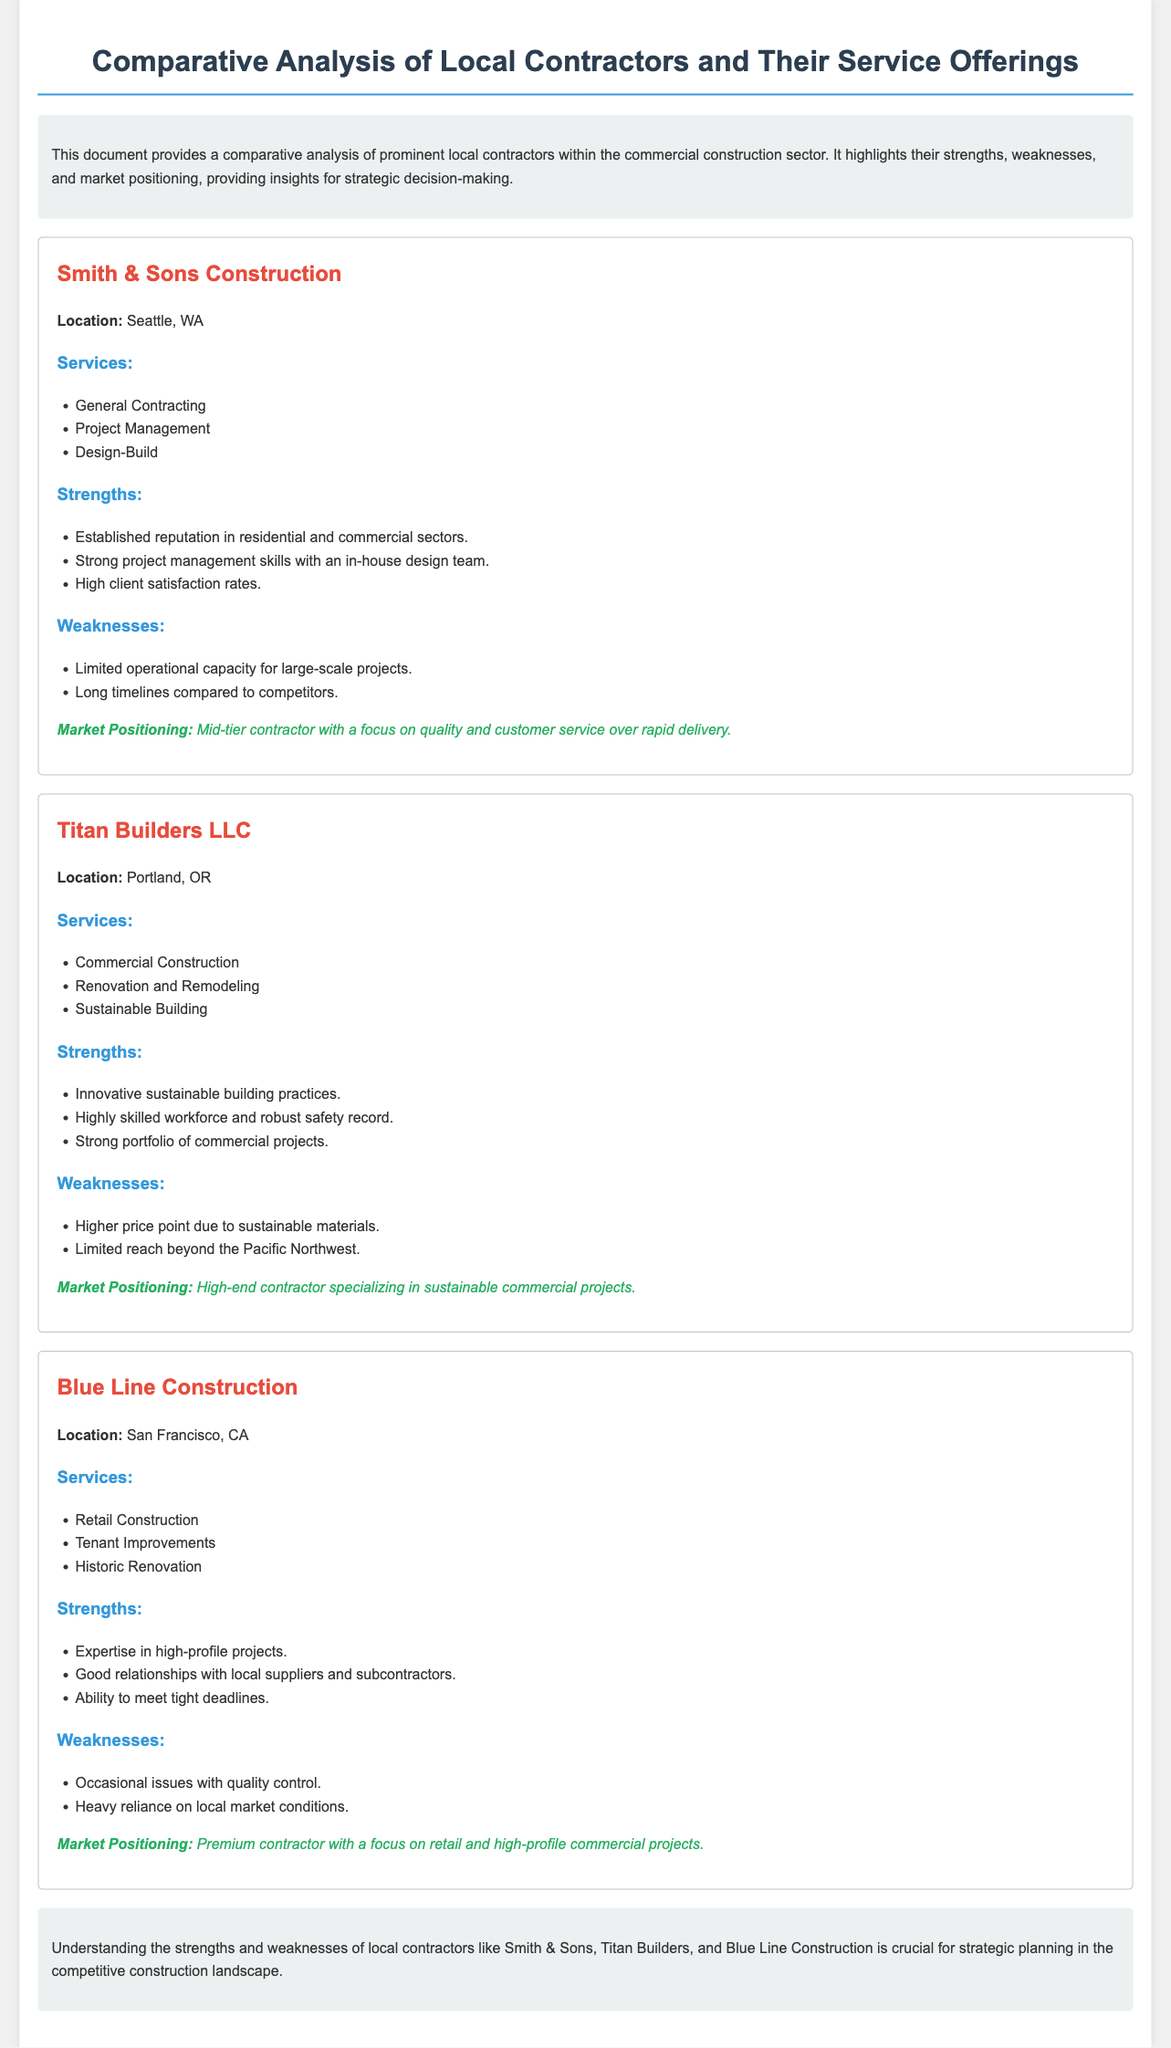What is the location of Smith & Sons Construction? The document specifies that Smith & Sons Construction is located in Seattle, WA.
Answer: Seattle, WA What services does Titan Builders LLC offer? The services listed for Titan Builders LLC include Commercial Construction, Renovation and Remodeling, and Sustainable Building.
Answer: Commercial Construction, Renovation and Remodeling, Sustainable Building What is a strength of Blue Line Construction? The document states that one strength of Blue Line Construction is their expertise in high-profile projects.
Answer: Expertise in high-profile projects What is the market positioning of Titan Builders LLC? According to the document, Titan Builders LLC is positioned as a high-end contractor specializing in sustainable commercial projects.
Answer: High-end contractor specializing in sustainable commercial projects What is a weakness associated with Smith & Sons Construction? The document lists long timelines compared to competitors as a weakness of Smith & Sons Construction.
Answer: Long timelines compared to competitors Which contractor is described as having a strong portfolio of commercial projects? The document highlights Titan Builders LLC as having a strong portfolio of commercial projects.
Answer: Titan Builders LLC What type of construction does Blue Line Construction specialize in? Blue Line Construction specializes in retail construction according to the document.
Answer: Retail construction What is the overall focus of Smith & Sons Construction? The document indicates that Smith & Sons Construction focuses on quality and customer service over rapid delivery.
Answer: Quality and customer service over rapid delivery What describes the operational capacity of Smith & Sons Construction? The document states that Smith & Sons Construction has limited operational capacity for large-scale projects.
Answer: Limited operational capacity for large-scale projects What kind of contractor is Blue Line Construction? The document classifies Blue Line Construction as a premium contractor with a focus on retail and high-profile commercial projects.
Answer: Premium contractor with a focus on retail and high-profile commercial projects 